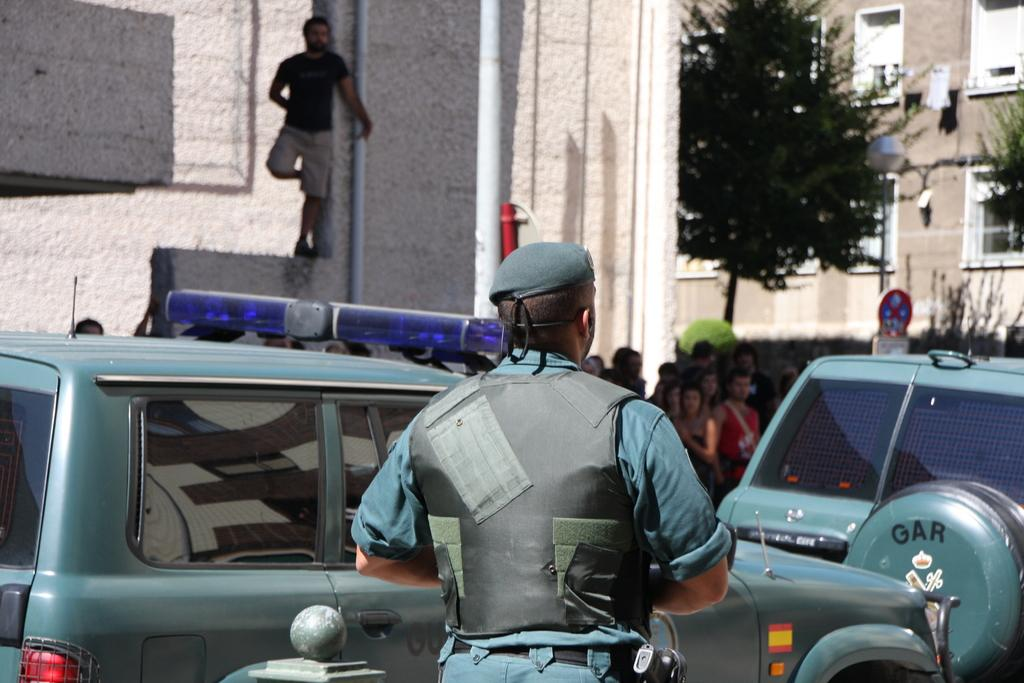What is the main subject in the image? There is a vehicle in the image. Can you describe the person in the image? There is one person in the image. What can be seen in the background of the image? There is a group of people, a board, poles, trees, and buildings with windows in the background of the image. What type of garden can be seen in the image? There is no garden present in the image. How does the sleet affect the trees in the image? There is no sleet present in the image, and therefore no effect on the trees can be observed. 